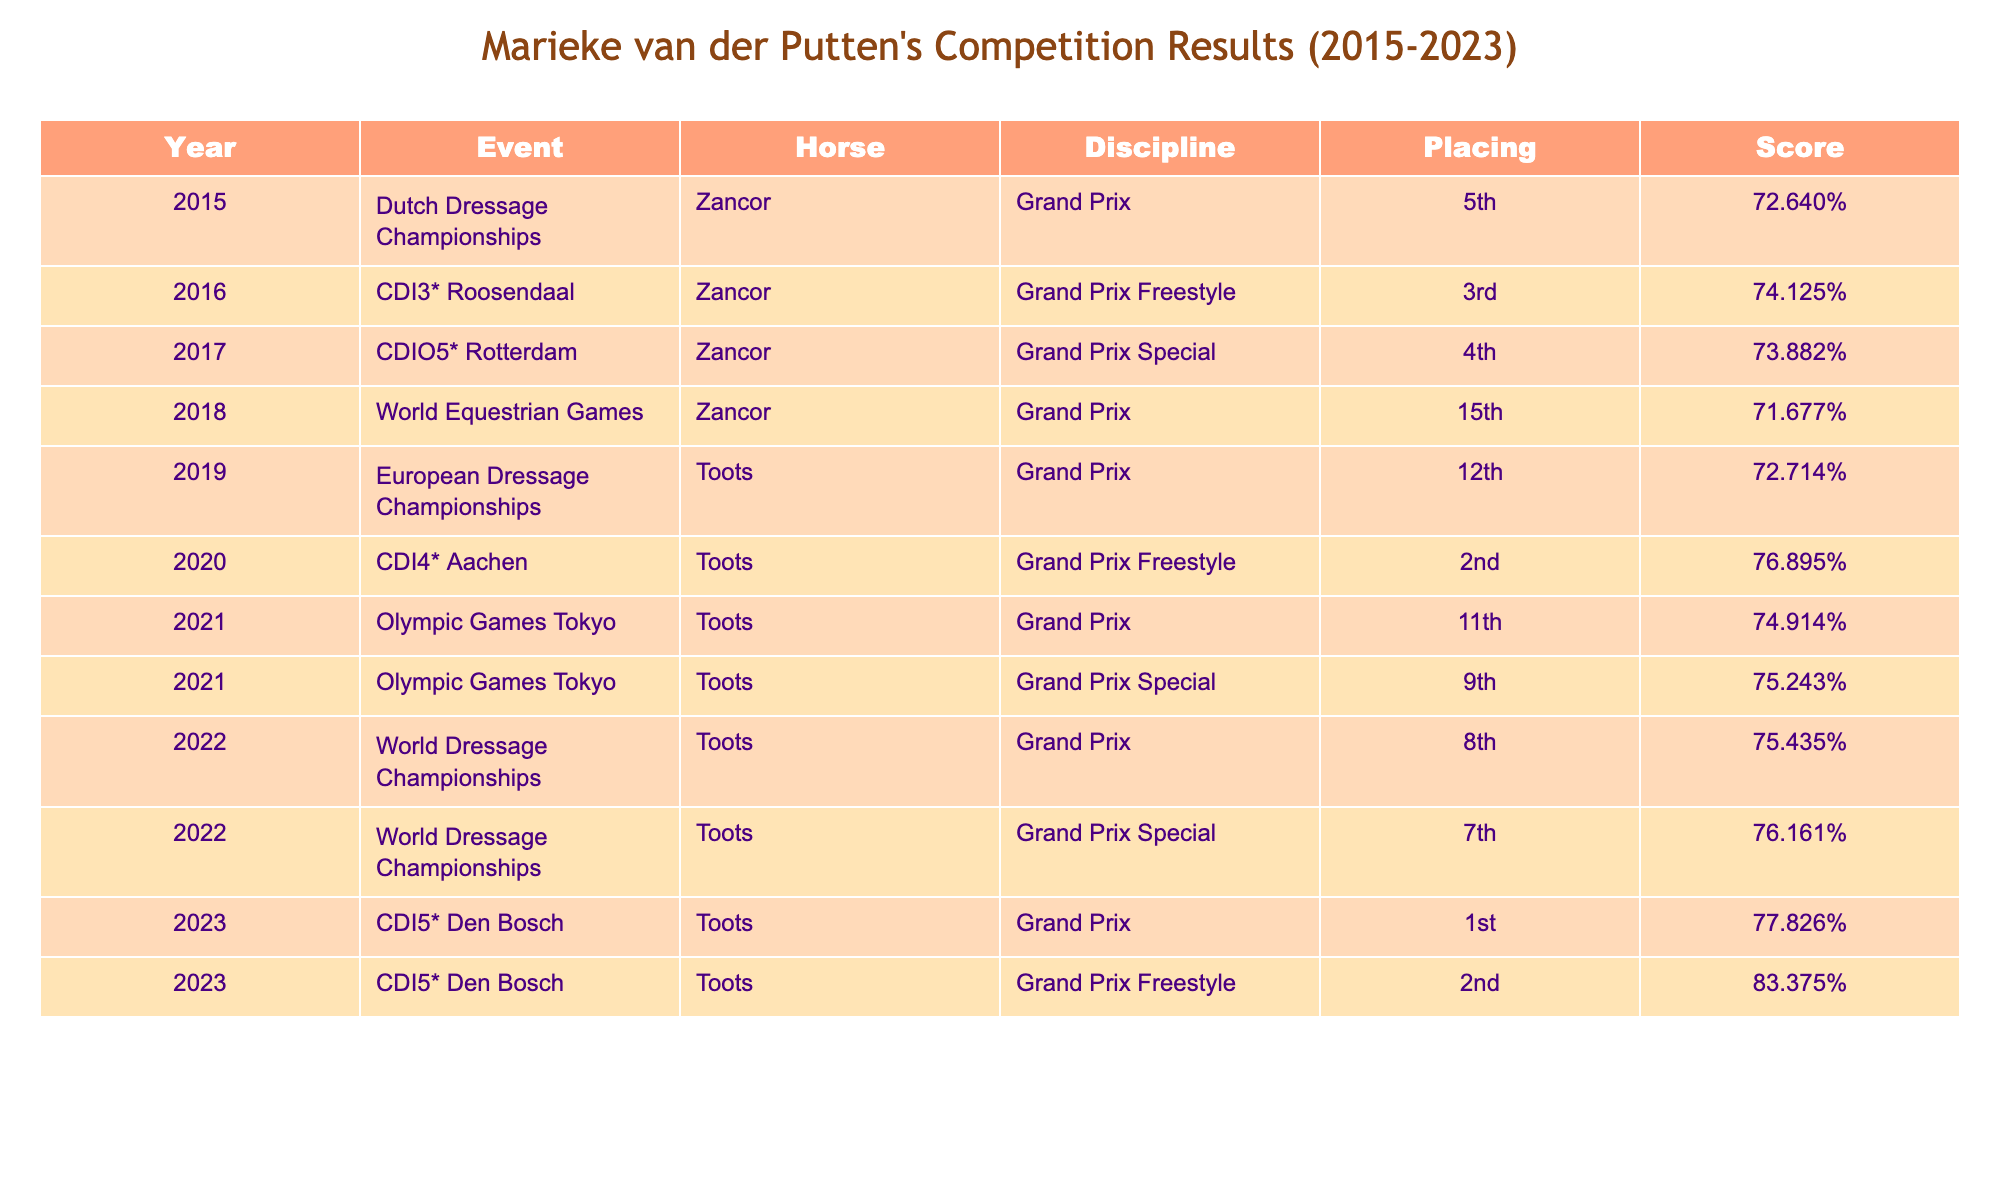What position did Marieke achieve in the 2023 CDI5* Den Bosch Grand Prix? The table shows that Marieke placed 1st in the 2023 CDI5* Den Bosch Grand Prix.
Answer: 1st How many competitions did Marieke compete in during the year 2022? The table lists two events in 2022 where Marieke competed: both in the World Dressage Championships.
Answer: 2 What was Marieke's highest score listed in the table? The highest score in the table is 83.375% from the Grand Prix Freestyle in 2023 at CDI5* Den Bosch.
Answer: 83.375% Did Marieke's horse Toots win any events from 2020 to 2023? Yes, Toots won 1st place in the 2023 CDI5* Den Bosch Grand Prix.
Answer: Yes What was the average placing of Marieke in the Grand Prix discipline from 2015 to 2023? The placings in the Grand Prix are: 5th, 15th, 12th, 11th, 8th, and 1st. Adding them gives 5 + 15 + 12 + 11 + 8 + 1 = 52. There are 6 events, so the average is 52/6 = 8.67, rounding gives an average placing of 9.
Answer: 9 How many times did Marieke compete in the Grand Prix Special events? From the table, Marieke competed in 3 Grand Prix Special events: in 2017 and twice in 2021.
Answer: 3 What percentage of competitions did Marieke place in the top 5 between 2015 and 2023? She placed in the top 5 in 4 events out of 12 listed competitions. The percentage is (4 / 12) * 100 = 33.33%.
Answer: 33.33% In which event and year did Marieke score the lowest? The lowest score is 71.677%, which she achieved in the 2018 World Equestrian Games.
Answer: 2018 World Equestrian Games How did Marieke's placement change from the European Dressage Championships in 2019 to the World Dressage Championships in 2022? Marieke placed 12th in the 2019 European Dressage Championships and improved to 8th in the 2022 World Dressage Championships, indicating a rise of 4 places.
Answer: Improved by 4 places How many times did Marieke compete with the horse Zancor? According to the table, Marieke competed 4 times with the horse Zancor in various events from 2015 to 2018.
Answer: 4 